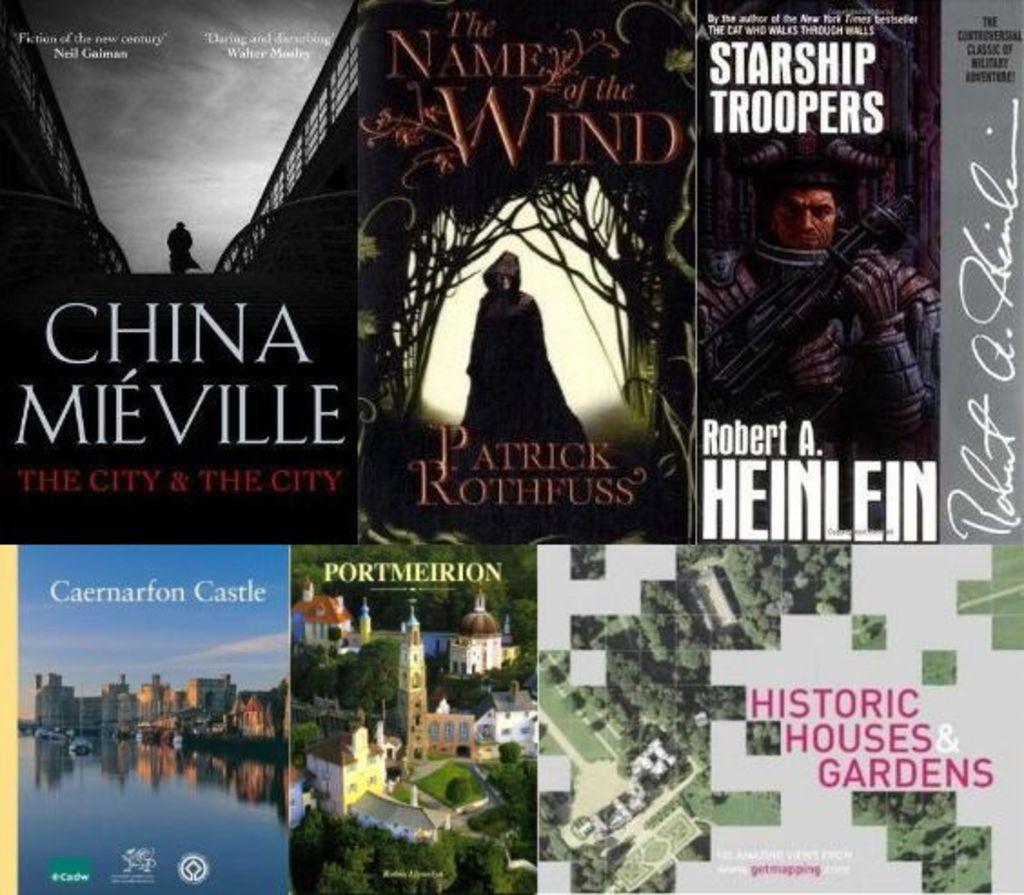Is there a book by heinlein here?
Offer a terse response. Yes. 